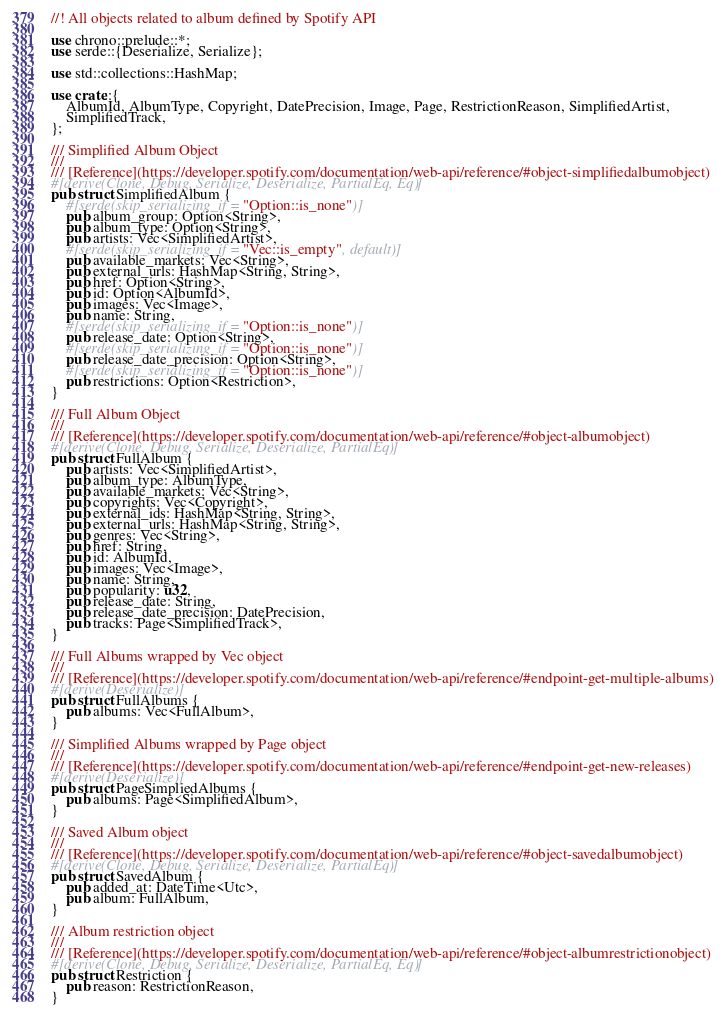<code> <loc_0><loc_0><loc_500><loc_500><_Rust_>//! All objects related to album defined by Spotify API

use chrono::prelude::*;
use serde::{Deserialize, Serialize};

use std::collections::HashMap;

use crate::{
    AlbumId, AlbumType, Copyright, DatePrecision, Image, Page, RestrictionReason, SimplifiedArtist,
    SimplifiedTrack,
};

/// Simplified Album Object
///
/// [Reference](https://developer.spotify.com/documentation/web-api/reference/#object-simplifiedalbumobject)
#[derive(Clone, Debug, Serialize, Deserialize, PartialEq, Eq)]
pub struct SimplifiedAlbum {
    #[serde(skip_serializing_if = "Option::is_none")]
    pub album_group: Option<String>,
    pub album_type: Option<String>,
    pub artists: Vec<SimplifiedArtist>,
    #[serde(skip_serializing_if = "Vec::is_empty", default)]
    pub available_markets: Vec<String>,
    pub external_urls: HashMap<String, String>,
    pub href: Option<String>,
    pub id: Option<AlbumId>,
    pub images: Vec<Image>,
    pub name: String,
    #[serde(skip_serializing_if = "Option::is_none")]
    pub release_date: Option<String>,
    #[serde(skip_serializing_if = "Option::is_none")]
    pub release_date_precision: Option<String>,
    #[serde(skip_serializing_if = "Option::is_none")]
    pub restrictions: Option<Restriction>,
}

/// Full Album Object
///
/// [Reference](https://developer.spotify.com/documentation/web-api/reference/#object-albumobject)
#[derive(Clone, Debug, Serialize, Deserialize, PartialEq)]
pub struct FullAlbum {
    pub artists: Vec<SimplifiedArtist>,
    pub album_type: AlbumType,
    pub available_markets: Vec<String>,
    pub copyrights: Vec<Copyright>,
    pub external_ids: HashMap<String, String>,
    pub external_urls: HashMap<String, String>,
    pub genres: Vec<String>,
    pub href: String,
    pub id: AlbumId,
    pub images: Vec<Image>,
    pub name: String,
    pub popularity: u32,
    pub release_date: String,
    pub release_date_precision: DatePrecision,
    pub tracks: Page<SimplifiedTrack>,
}

/// Full Albums wrapped by Vec object
///
/// [Reference](https://developer.spotify.com/documentation/web-api/reference/#endpoint-get-multiple-albums)
#[derive(Deserialize)]
pub struct FullAlbums {
    pub albums: Vec<FullAlbum>,
}

/// Simplified Albums wrapped by Page object
///
/// [Reference](https://developer.spotify.com/documentation/web-api/reference/#endpoint-get-new-releases)
#[derive(Deserialize)]
pub struct PageSimpliedAlbums {
    pub albums: Page<SimplifiedAlbum>,
}

/// Saved Album object
///
/// [Reference](https://developer.spotify.com/documentation/web-api/reference/#object-savedalbumobject)
#[derive(Clone, Debug, Serialize, Deserialize, PartialEq)]
pub struct SavedAlbum {
    pub added_at: DateTime<Utc>,
    pub album: FullAlbum,
}

/// Album restriction object
///
/// [Reference](https://developer.spotify.com/documentation/web-api/reference/#object-albumrestrictionobject)
#[derive(Clone, Debug, Serialize, Deserialize, PartialEq, Eq)]
pub struct Restriction {
    pub reason: RestrictionReason,
}
</code> 